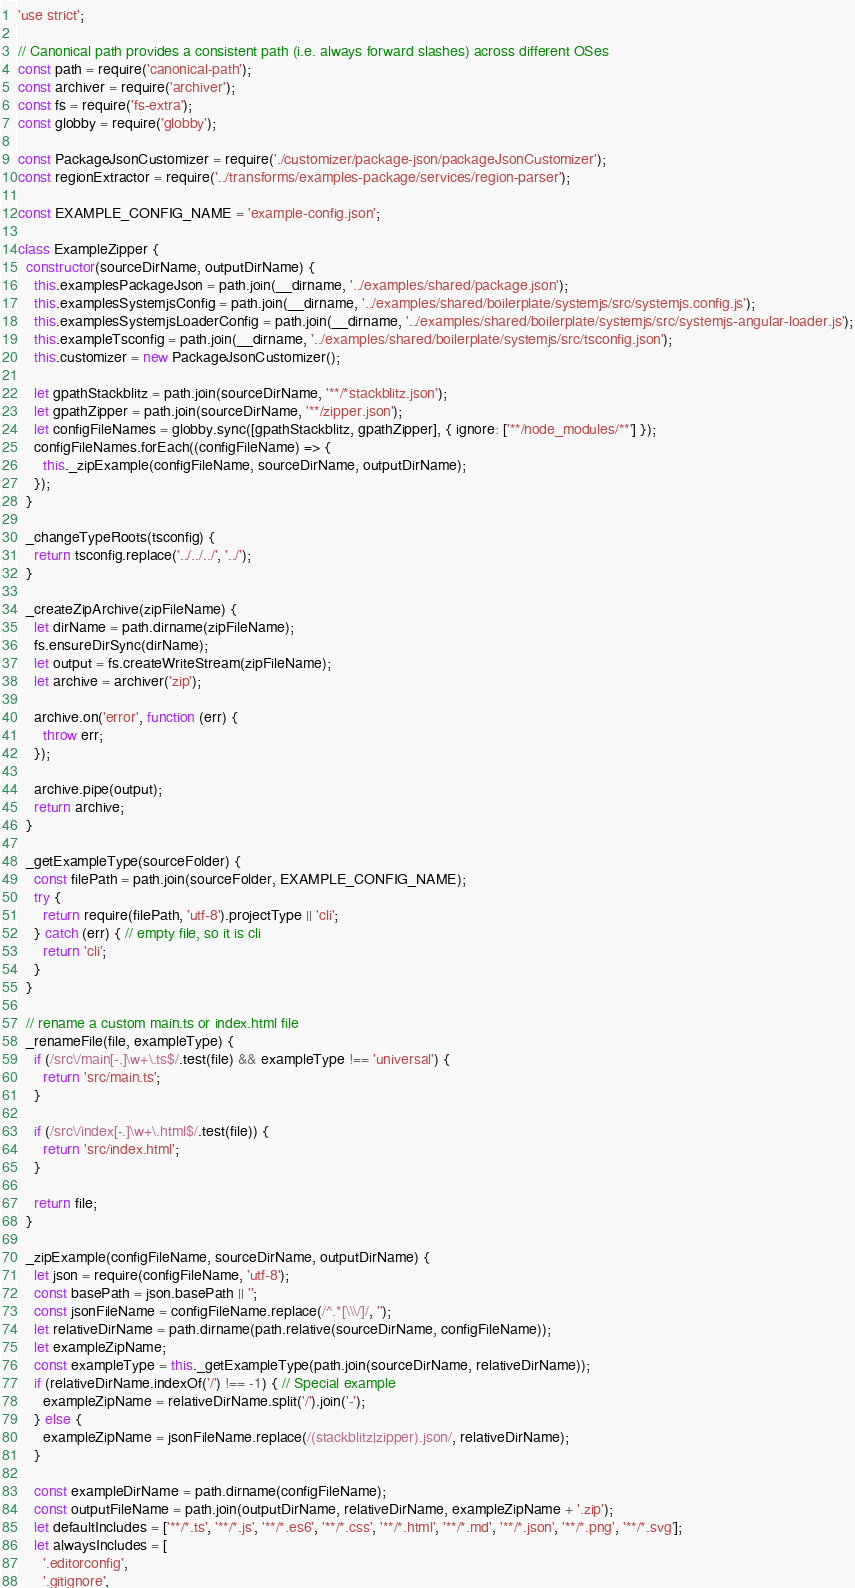<code> <loc_0><loc_0><loc_500><loc_500><_JavaScript_>'use strict';

// Canonical path provides a consistent path (i.e. always forward slashes) across different OSes
const path = require('canonical-path');
const archiver = require('archiver');
const fs = require('fs-extra');
const globby = require('globby');

const PackageJsonCustomizer = require('./customizer/package-json/packageJsonCustomizer');
const regionExtractor = require('../transforms/examples-package/services/region-parser');

const EXAMPLE_CONFIG_NAME = 'example-config.json';

class ExampleZipper {
  constructor(sourceDirName, outputDirName) {
    this.examplesPackageJson = path.join(__dirname, '../examples/shared/package.json');
    this.examplesSystemjsConfig = path.join(__dirname, '../examples/shared/boilerplate/systemjs/src/systemjs.config.js');
    this.examplesSystemjsLoaderConfig = path.join(__dirname, '../examples/shared/boilerplate/systemjs/src/systemjs-angular-loader.js');
    this.exampleTsconfig = path.join(__dirname, '../examples/shared/boilerplate/systemjs/src/tsconfig.json');
    this.customizer = new PackageJsonCustomizer();

    let gpathStackblitz = path.join(sourceDirName, '**/*stackblitz.json');
    let gpathZipper = path.join(sourceDirName, '**/zipper.json');
    let configFileNames = globby.sync([gpathStackblitz, gpathZipper], { ignore: ['**/node_modules/**'] });
    configFileNames.forEach((configFileName) => {
      this._zipExample(configFileName, sourceDirName, outputDirName);
    });
  }

  _changeTypeRoots(tsconfig) {
    return tsconfig.replace('../../../', '../');
  }

  _createZipArchive(zipFileName) {
    let dirName = path.dirname(zipFileName);
    fs.ensureDirSync(dirName);
    let output = fs.createWriteStream(zipFileName);
    let archive = archiver('zip');

    archive.on('error', function (err) {
      throw err;
    });

    archive.pipe(output);
    return archive;
  }

  _getExampleType(sourceFolder) {
    const filePath = path.join(sourceFolder, EXAMPLE_CONFIG_NAME);
    try {
      return require(filePath, 'utf-8').projectType || 'cli';
    } catch (err) { // empty file, so it is cli
      return 'cli';
    }
  }

  // rename a custom main.ts or index.html file
  _renameFile(file, exampleType) {
    if (/src\/main[-.]\w+\.ts$/.test(file) && exampleType !== 'universal') {
      return 'src/main.ts';
    }

    if (/src\/index[-.]\w+\.html$/.test(file)) {
      return 'src/index.html';
    }

    return file;
  }

  _zipExample(configFileName, sourceDirName, outputDirName) {
    let json = require(configFileName, 'utf-8');
    const basePath = json.basePath || '';
    const jsonFileName = configFileName.replace(/^.*[\\\/]/, '');
    let relativeDirName = path.dirname(path.relative(sourceDirName, configFileName));
    let exampleZipName;
    const exampleType = this._getExampleType(path.join(sourceDirName, relativeDirName));
    if (relativeDirName.indexOf('/') !== -1) { // Special example
      exampleZipName = relativeDirName.split('/').join('-');
    } else {
      exampleZipName = jsonFileName.replace(/(stackblitz|zipper).json/, relativeDirName);
    }

    const exampleDirName = path.dirname(configFileName);
    const outputFileName = path.join(outputDirName, relativeDirName, exampleZipName + '.zip');
    let defaultIncludes = ['**/*.ts', '**/*.js', '**/*.es6', '**/*.css', '**/*.html', '**/*.md', '**/*.json', '**/*.png', '**/*.svg'];
    let alwaysIncludes = [
      '.editorconfig',
      '.gitignore',</code> 